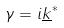<formula> <loc_0><loc_0><loc_500><loc_500>\gamma = i \underline { k } ^ { * }</formula> 